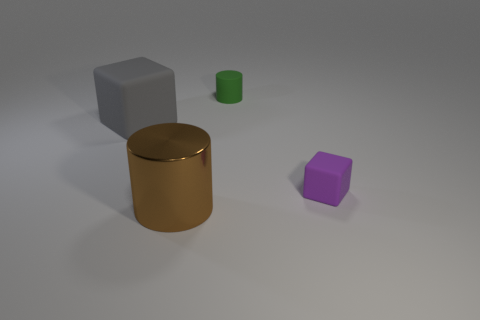Are there any other things that have the same material as the big cylinder? While I'm unable to determine the exact materials from an image, the big cylinder appears to have a reflective surface similar to metal. The small green cylinder also seems to have a reflective quality, although it's not as pronounced, suggesting it could be made of a similar material but with a different finish or alloy. 